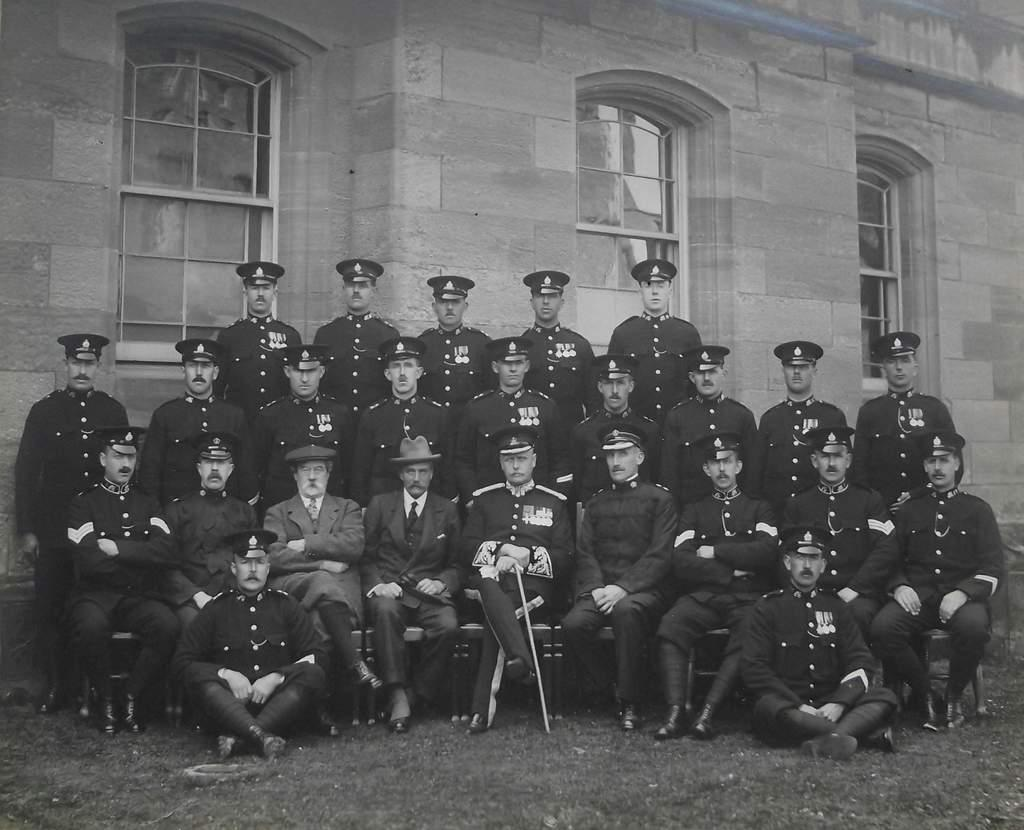How many people are in the image? There are people in the image, but the exact number is not specified. What can be observed about the clothing of the people in the image? The people are dressed in a similar manner. What position are the people in the image? The people are sitting on the ground. What type of surface is the people sitting on? There is grass on the ground. What type of structure is visible in the image? There is a wall with glass windows in the image. What type of vehicle are the people driving in the image? There is no vehicle present in the image; the people are sitting on the grass. Can you describe the cellar in the image? There is no cellar present in the image. 